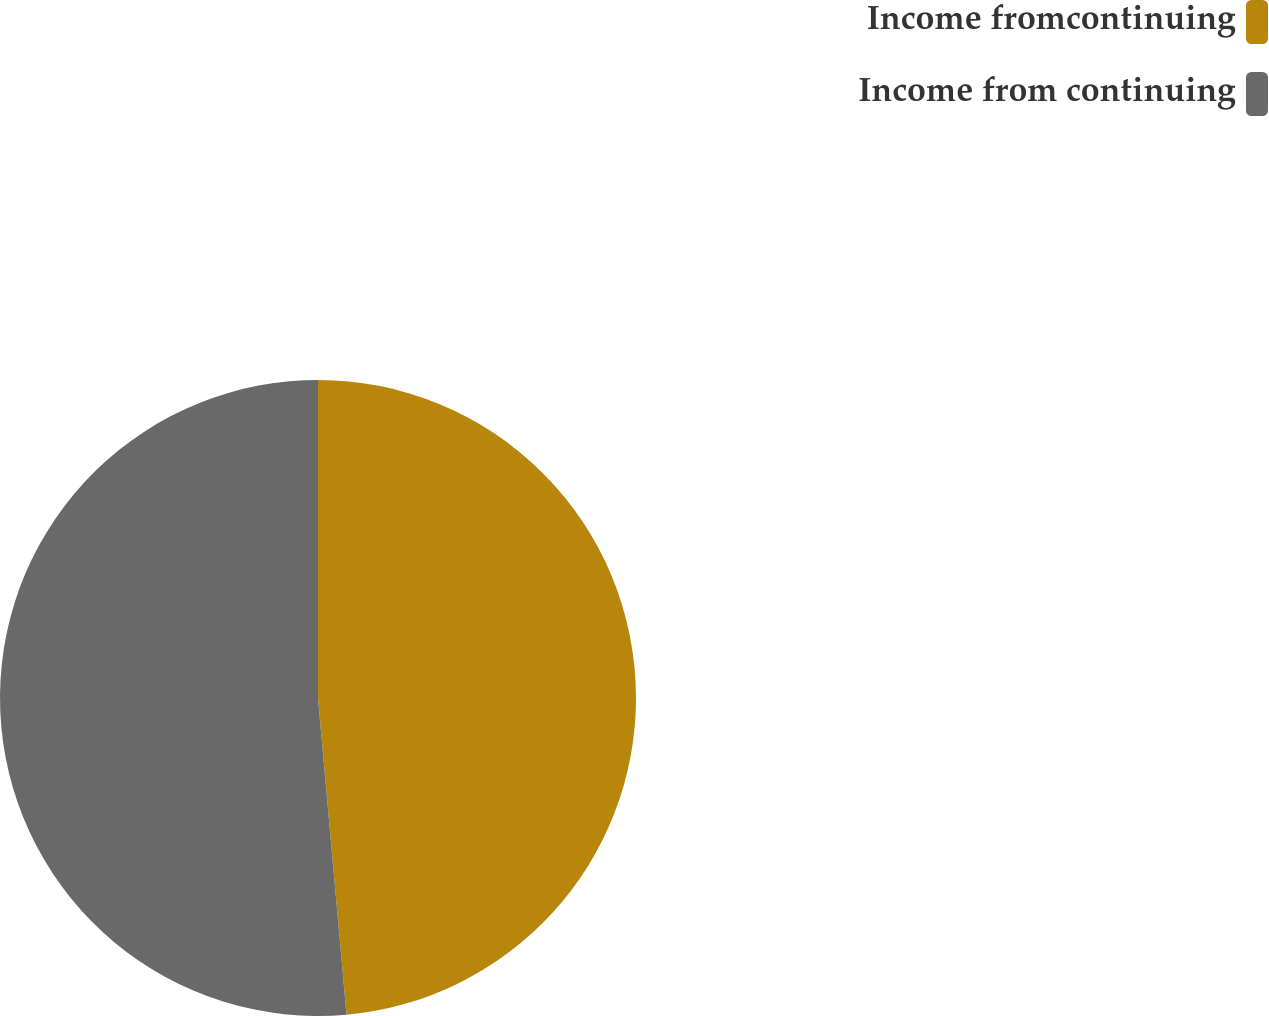<chart> <loc_0><loc_0><loc_500><loc_500><pie_chart><fcel>Income fromcontinuing<fcel>Income from continuing<nl><fcel>48.57%<fcel>51.43%<nl></chart> 